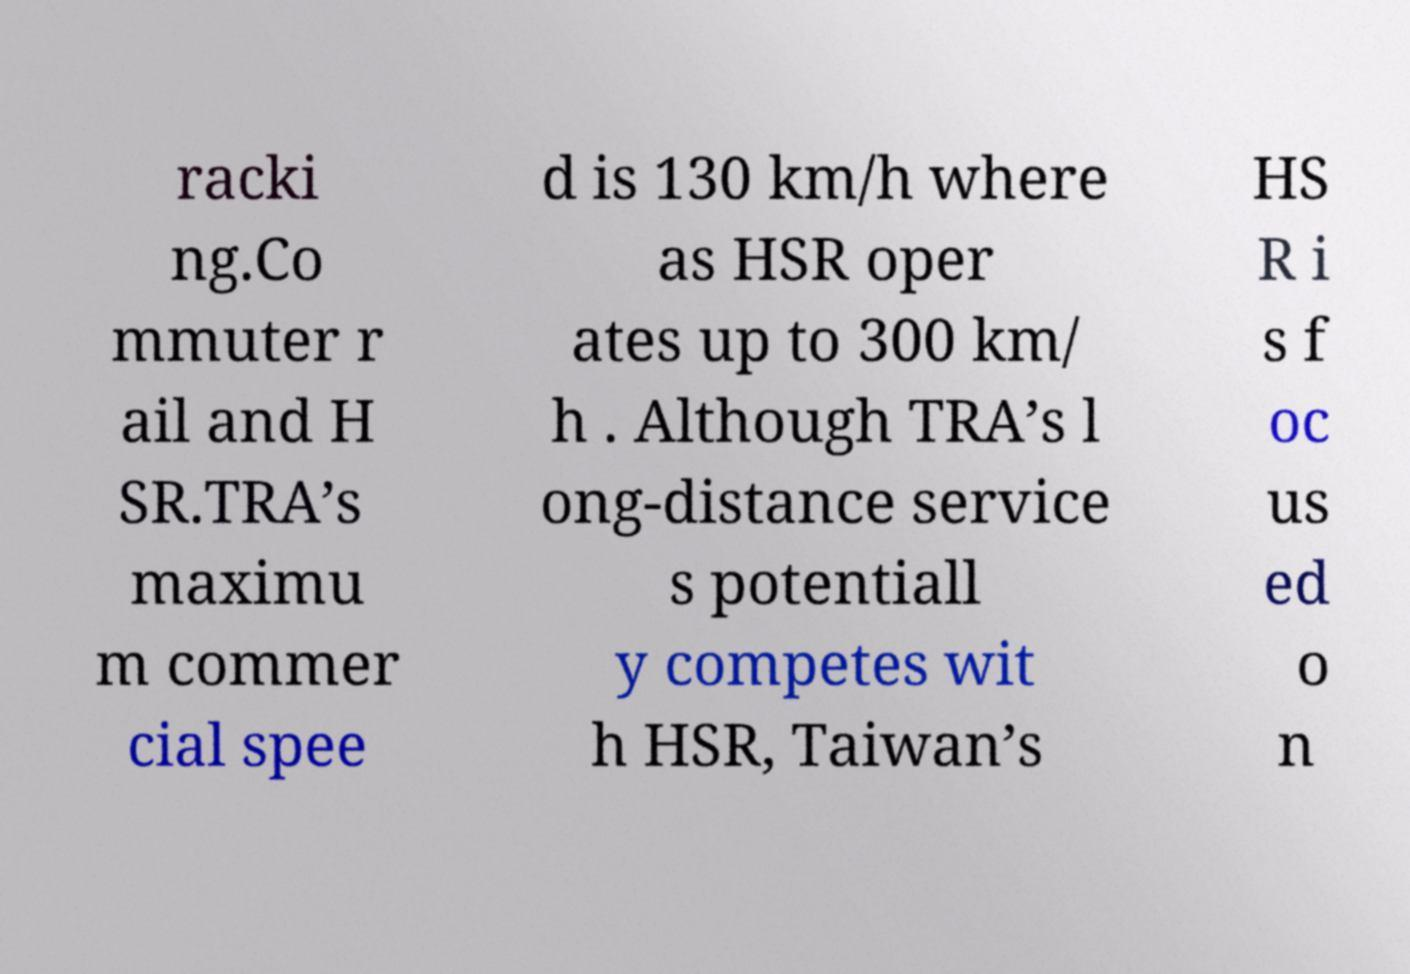For documentation purposes, I need the text within this image transcribed. Could you provide that? racki ng.Co mmuter r ail and H SR.TRA’s maximu m commer cial spee d is 130 km/h where as HSR oper ates up to 300 km/ h . Although TRA’s l ong-distance service s potentiall y competes wit h HSR, Taiwan’s HS R i s f oc us ed o n 